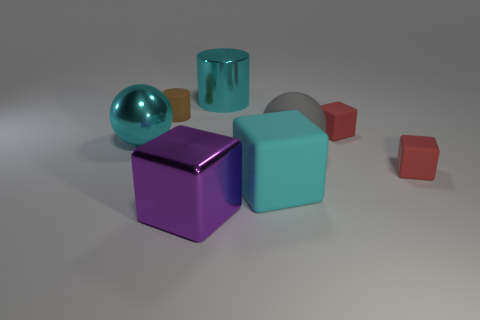Subtract all big purple cubes. How many cubes are left? 3 Add 2 large matte cubes. How many objects exist? 10 Subtract 1 cubes. How many cubes are left? 3 Subtract all purple blocks. How many blocks are left? 3 Subtract all spheres. How many objects are left? 6 Subtract all blue spheres. Subtract all tiny cubes. How many objects are left? 6 Add 6 large matte blocks. How many large matte blocks are left? 7 Add 3 cyan blocks. How many cyan blocks exist? 4 Subtract 0 green cylinders. How many objects are left? 8 Subtract all red blocks. Subtract all brown balls. How many blocks are left? 2 